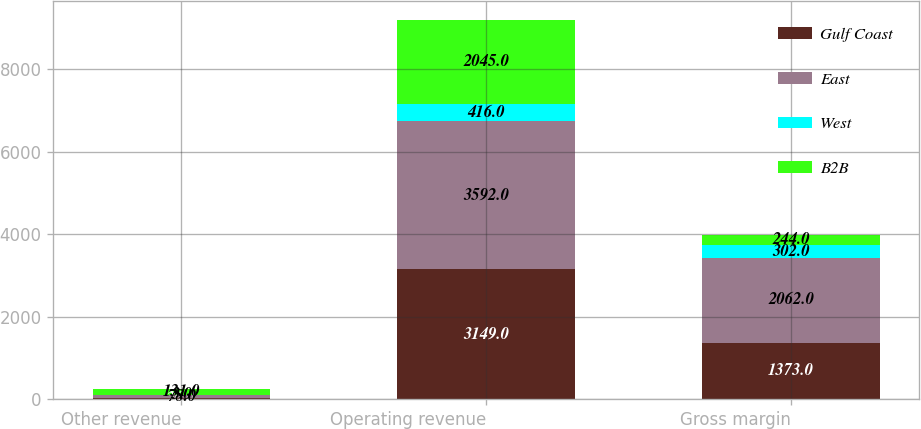Convert chart. <chart><loc_0><loc_0><loc_500><loc_500><stacked_bar_chart><ecel><fcel>Other revenue<fcel>Operating revenue<fcel>Gross margin<nl><fcel>Gulf Coast<fcel>26<fcel>3149<fcel>1373<nl><fcel>East<fcel>78<fcel>3592<fcel>2062<nl><fcel>West<fcel>3<fcel>416<fcel>302<nl><fcel>B2B<fcel>131<fcel>2045<fcel>244<nl></chart> 